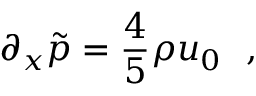<formula> <loc_0><loc_0><loc_500><loc_500>\partial _ { x } \tilde { p } = { \frac { 4 } { 5 } } \rho u _ { 0 } ,</formula> 